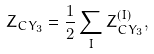<formula> <loc_0><loc_0><loc_500><loc_500>Z _ { C Y _ { 3 } } = \frac { 1 } { 2 } \sum _ { I } Z _ { C Y _ { 3 } } ^ { ( I ) } ,</formula> 